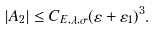<formula> <loc_0><loc_0><loc_500><loc_500>| A _ { 2 } | \leq C _ { E , \lambda , \sigma } ( \varepsilon + \varepsilon _ { 1 } ) ^ { 3 } .</formula> 